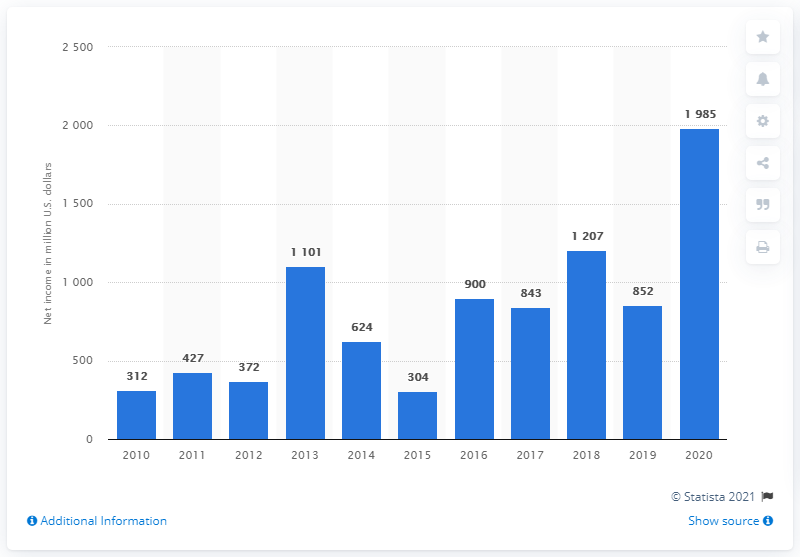Mention a couple of crucial points in this snapshot. In 2020, Celanese Corporation's net income was X. 